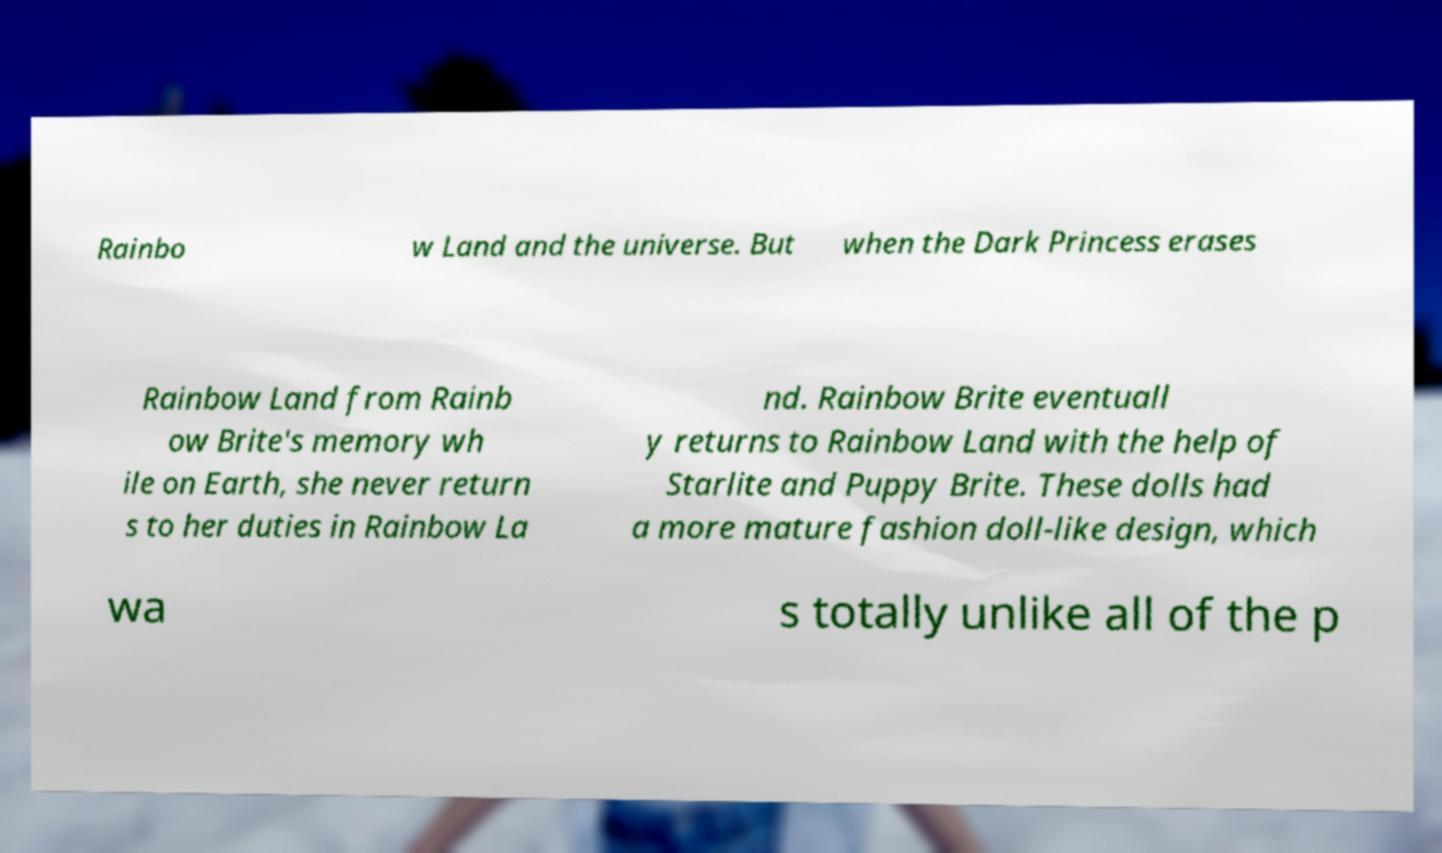What messages or text are displayed in this image? I need them in a readable, typed format. Rainbo w Land and the universe. But when the Dark Princess erases Rainbow Land from Rainb ow Brite's memory wh ile on Earth, she never return s to her duties in Rainbow La nd. Rainbow Brite eventuall y returns to Rainbow Land with the help of Starlite and Puppy Brite. These dolls had a more mature fashion doll-like design, which wa s totally unlike all of the p 